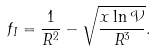<formula> <loc_0><loc_0><loc_500><loc_500>f _ { I } = \frac { 1 } { R ^ { 2 } } - \sqrt { \frac { x \ln \mathcal { V } } { R ^ { 3 } } } .</formula> 